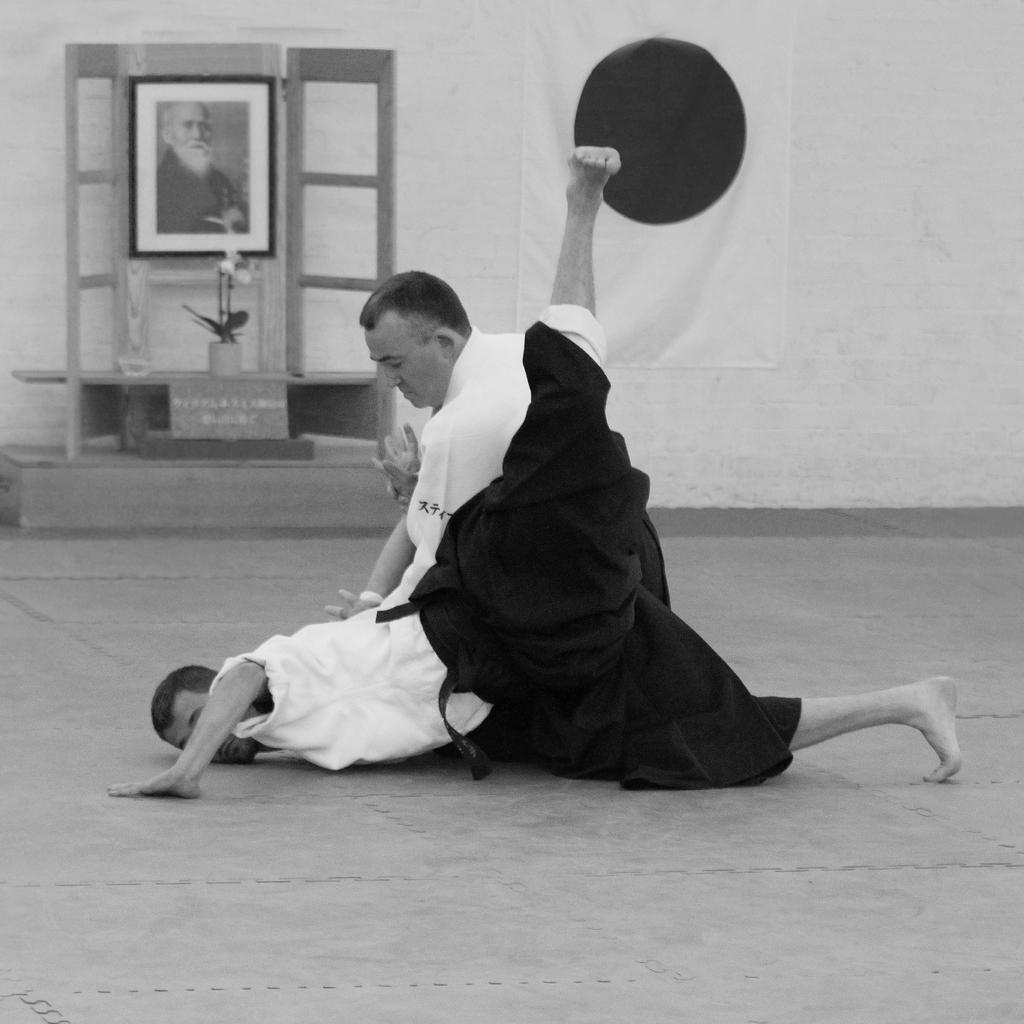What are the two persons in the image doing? The two persons in the image are practicing martial arts. What can be seen in the background of the image? In the background of the image, there is a frame, a flower vase, a board, a table, a wall, and a flag. What type of paper is being used by the martial artists in the image? There is no paper visible in the image; the two persons are practicing martial arts. What musical instrument is being played by the martial artists in the image? There is no musical instrument visible in the image; the two persons are practicing martial arts. What color is the sky in the image? The sky is not visible in the image, as it is focused on the martial artists and the background elements. 